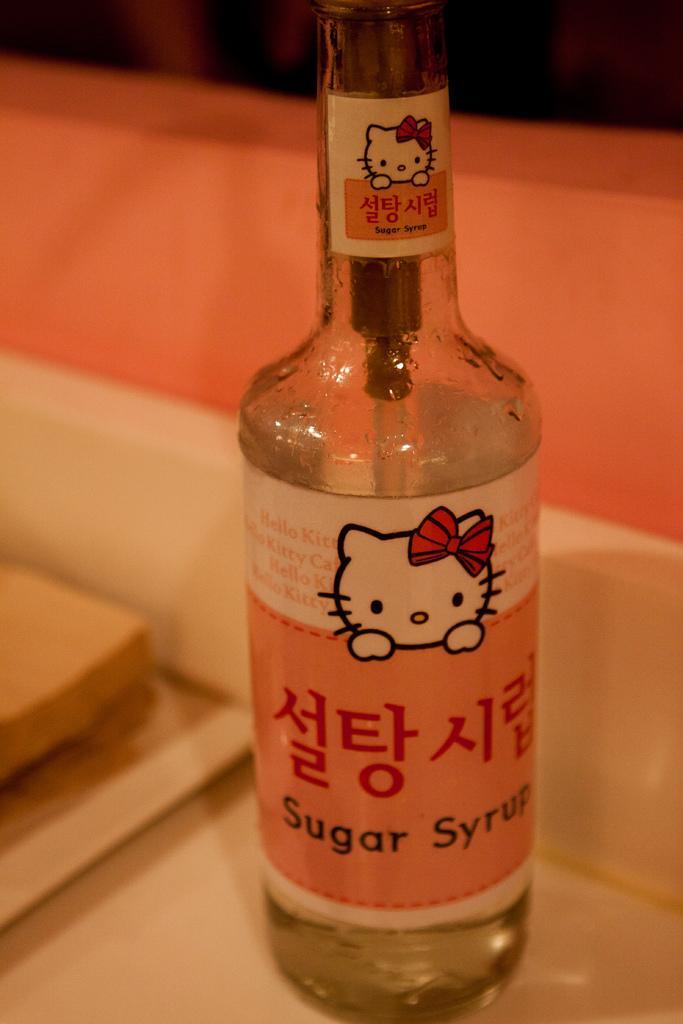Please provide a concise description of this image. In this picture, There is a bottle which is in orange color and there is a table which is in white color. 